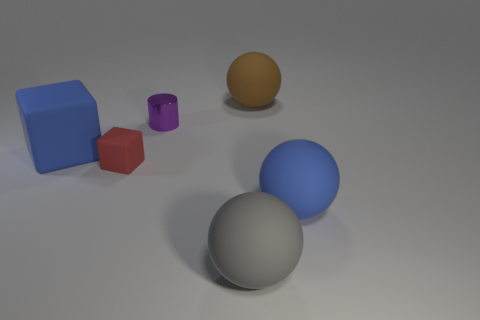How big is the rubber thing right of the large brown rubber ball?
Provide a short and direct response. Large. Are there any purple blocks made of the same material as the big blue cube?
Make the answer very short. No. How many blue things have the same shape as the large brown matte thing?
Your answer should be very brief. 1. There is a blue thing in front of the blue thing that is behind the blue rubber ball on the right side of the big gray matte thing; what shape is it?
Give a very brief answer. Sphere. There is a thing that is on the left side of the large gray matte sphere and on the right side of the tiny cube; what material is it?
Give a very brief answer. Metal. Do the blue matte object left of the purple object and the small red block have the same size?
Give a very brief answer. No. Is there anything else that is the same size as the gray matte ball?
Ensure brevity in your answer.  Yes. Is the number of small cylinders in front of the gray thing greater than the number of blue matte things to the left of the red cube?
Make the answer very short. No. What color is the large rubber ball that is on the right side of the ball that is behind the blue rubber object that is to the right of the large gray sphere?
Offer a terse response. Blue. Do the small object that is in front of the small purple shiny cylinder and the cylinder have the same color?
Your answer should be very brief. No. 